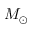Convert formula to latex. <formula><loc_0><loc_0><loc_500><loc_500>M _ { \odot }</formula> 